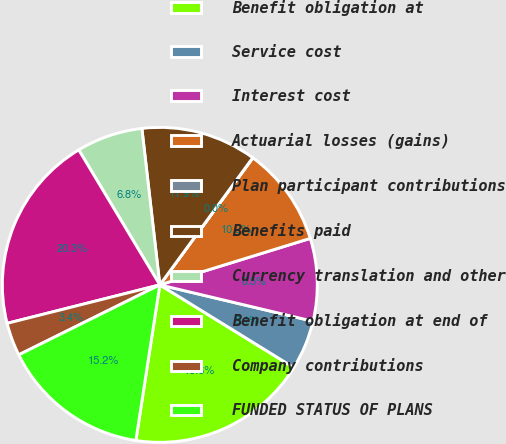Convert chart to OTSL. <chart><loc_0><loc_0><loc_500><loc_500><pie_chart><fcel>Benefit obligation at<fcel>Service cost<fcel>Interest cost<fcel>Actuarial losses (gains)<fcel>Plan participant contributions<fcel>Benefits paid<fcel>Currency translation and other<fcel>Benefit obligation at end of<fcel>Company contributions<fcel>FUNDED STATUS OF PLANS<nl><fcel>18.63%<fcel>5.09%<fcel>8.48%<fcel>10.17%<fcel>0.02%<fcel>11.86%<fcel>6.79%<fcel>20.32%<fcel>3.4%<fcel>15.24%<nl></chart> 